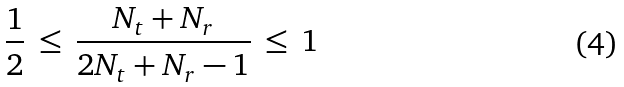Convert formula to latex. <formula><loc_0><loc_0><loc_500><loc_500>\frac { 1 } { 2 } \, \leq \, \frac { N _ { t } + N _ { r } } { 2 N _ { t } + N _ { r } - 1 } \, \leq \, 1</formula> 